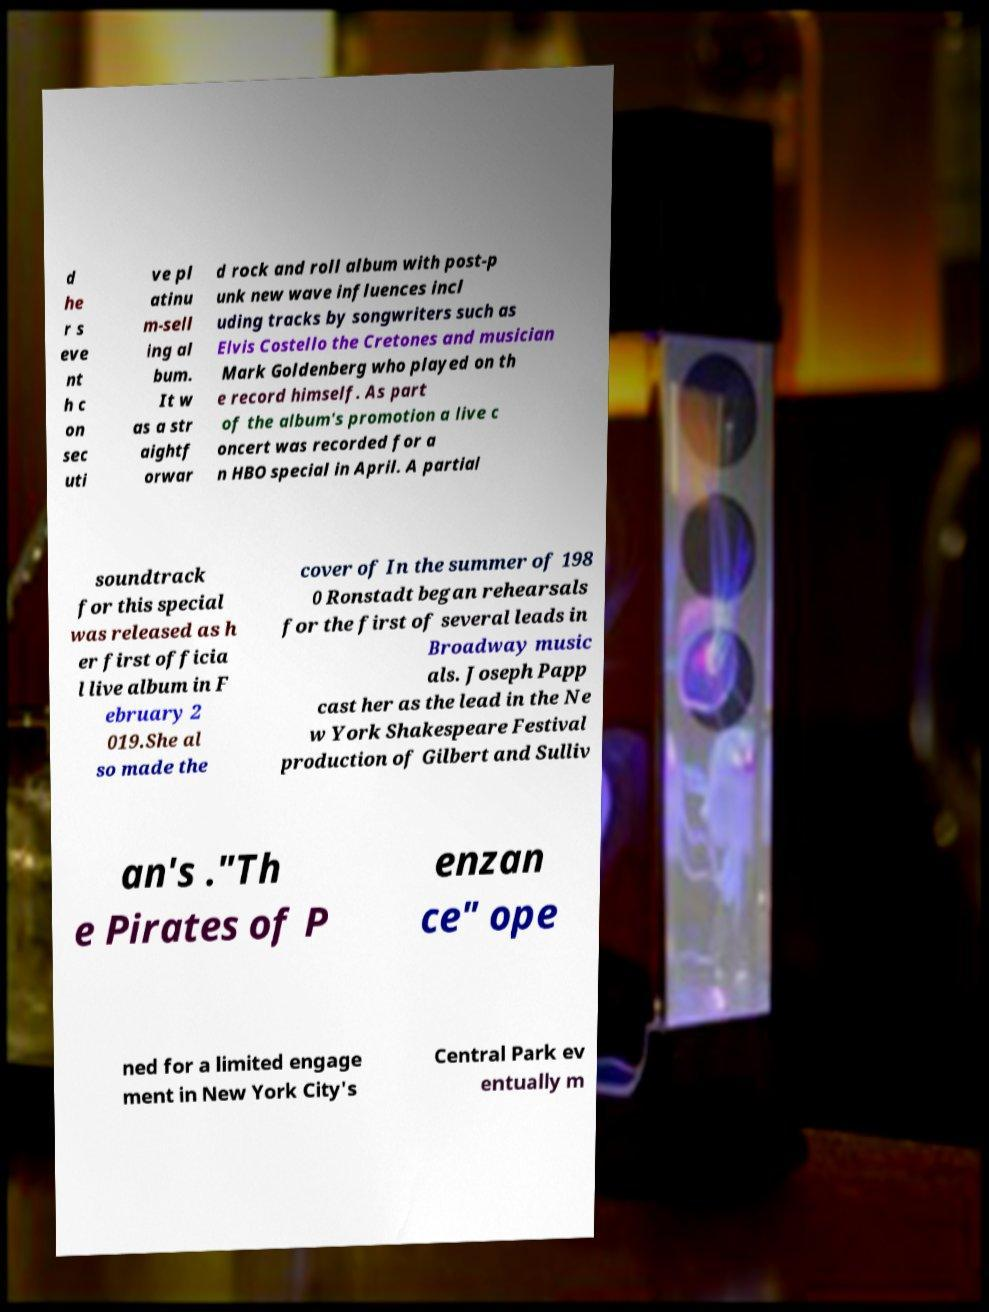I need the written content from this picture converted into text. Can you do that? d he r s eve nt h c on sec uti ve pl atinu m-sell ing al bum. It w as a str aightf orwar d rock and roll album with post-p unk new wave influences incl uding tracks by songwriters such as Elvis Costello the Cretones and musician Mark Goldenberg who played on th e record himself. As part of the album's promotion a live c oncert was recorded for a n HBO special in April. A partial soundtrack for this special was released as h er first officia l live album in F ebruary 2 019.She al so made the cover of In the summer of 198 0 Ronstadt began rehearsals for the first of several leads in Broadway music als. Joseph Papp cast her as the lead in the Ne w York Shakespeare Festival production of Gilbert and Sulliv an's ."Th e Pirates of P enzan ce" ope ned for a limited engage ment in New York City's Central Park ev entually m 